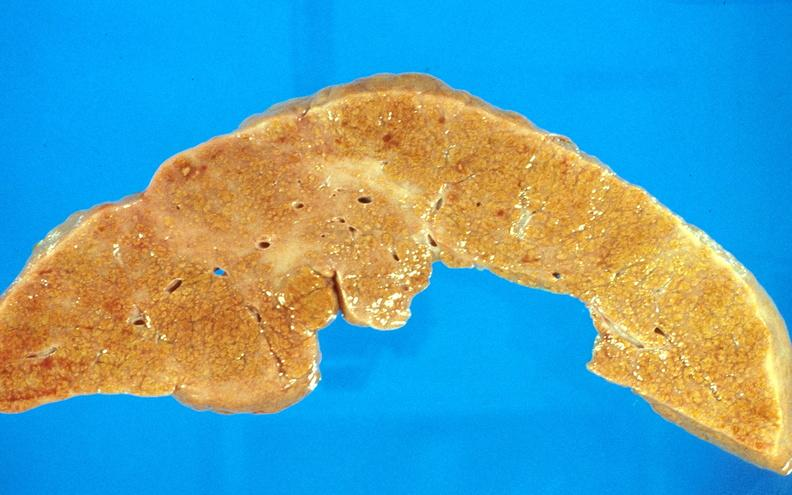what does this image show?
Answer the question using a single word or phrase. Cirrhosis 